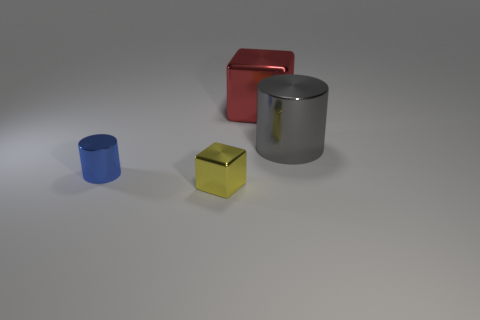Add 4 tiny yellow shiny cubes. How many objects exist? 8 Subtract all purple cylinders. Subtract all gray blocks. How many cylinders are left? 2 Subtract all gray blocks. How many red cylinders are left? 0 Subtract all yellow things. Subtract all cylinders. How many objects are left? 1 Add 1 big red metallic blocks. How many big red metallic blocks are left? 2 Add 2 cyan metallic cylinders. How many cyan metallic cylinders exist? 2 Subtract 0 cyan cubes. How many objects are left? 4 